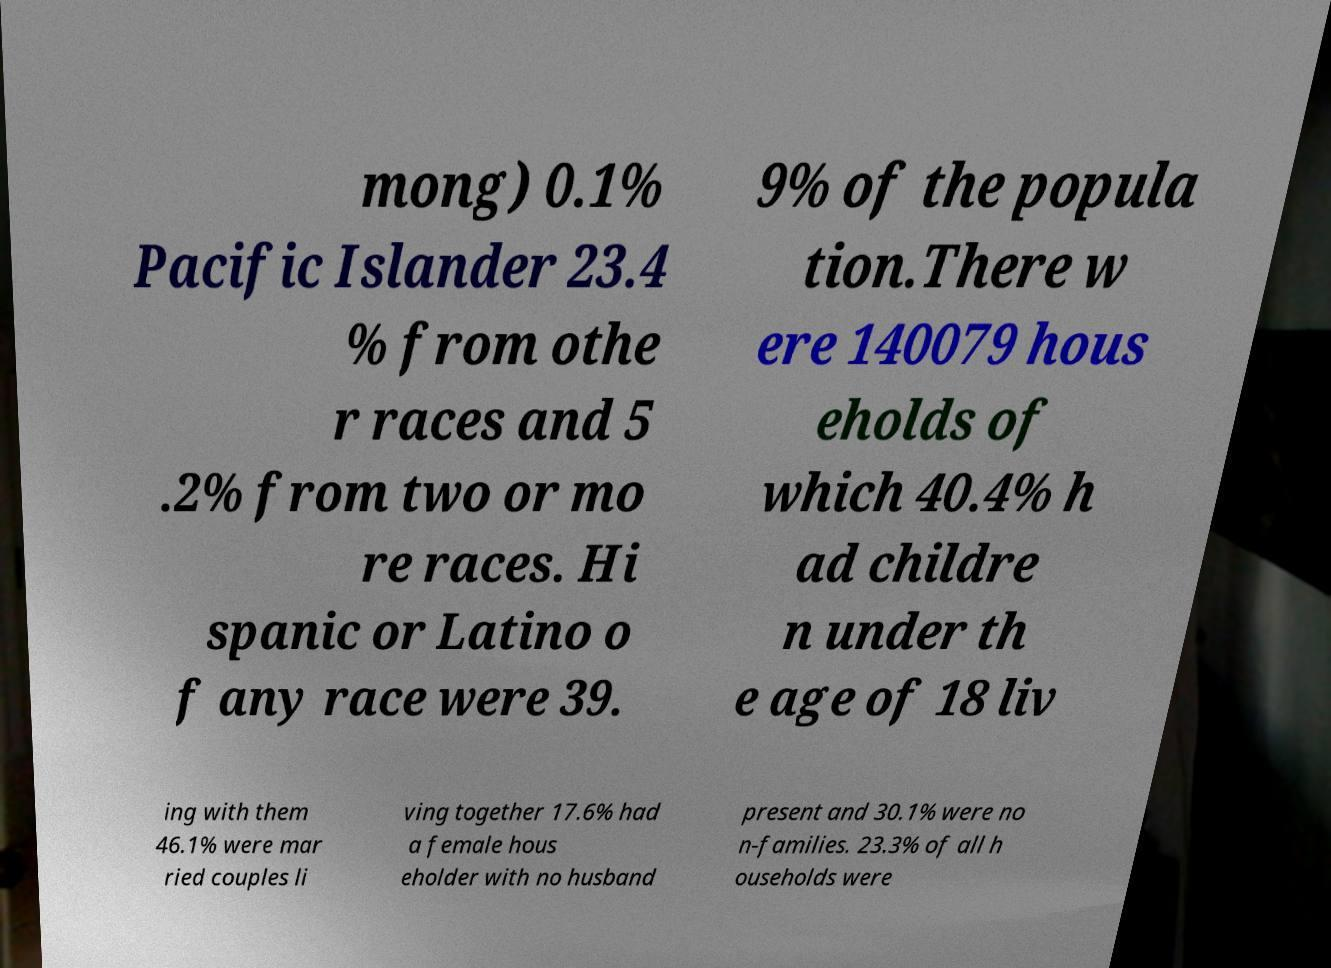What messages or text are displayed in this image? I need them in a readable, typed format. mong) 0.1% Pacific Islander 23.4 % from othe r races and 5 .2% from two or mo re races. Hi spanic or Latino o f any race were 39. 9% of the popula tion.There w ere 140079 hous eholds of which 40.4% h ad childre n under th e age of 18 liv ing with them 46.1% were mar ried couples li ving together 17.6% had a female hous eholder with no husband present and 30.1% were no n-families. 23.3% of all h ouseholds were 